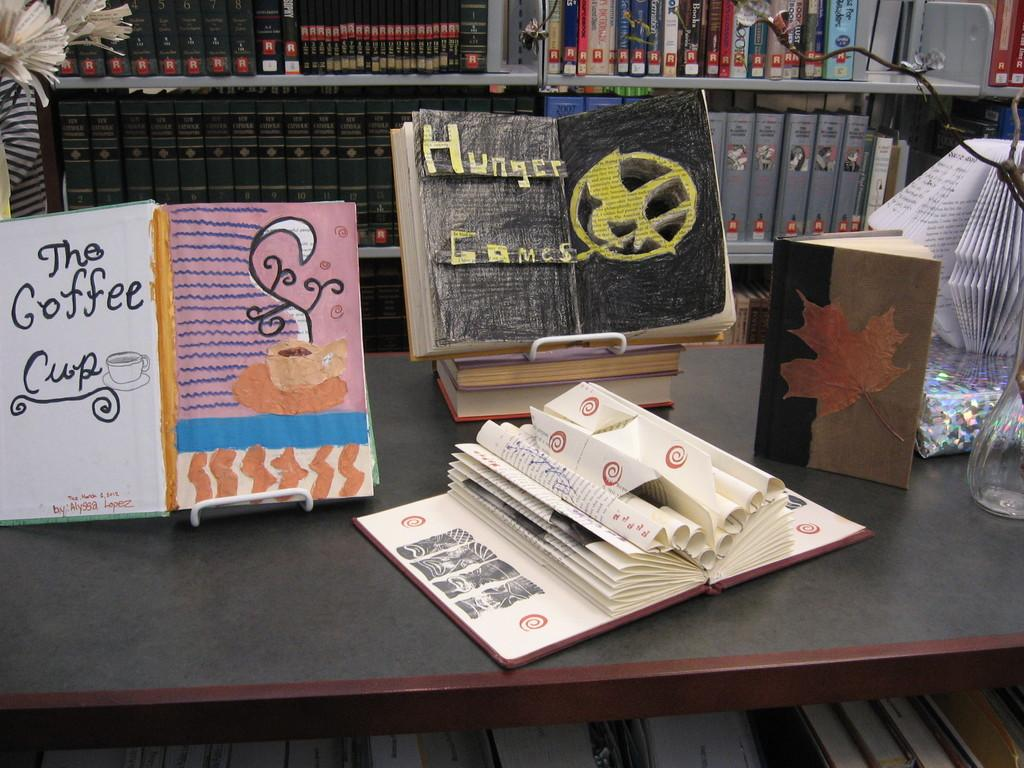<image>
Summarize the visual content of the image. A handmade cover for the book Hunger Games drawn in crayon. 